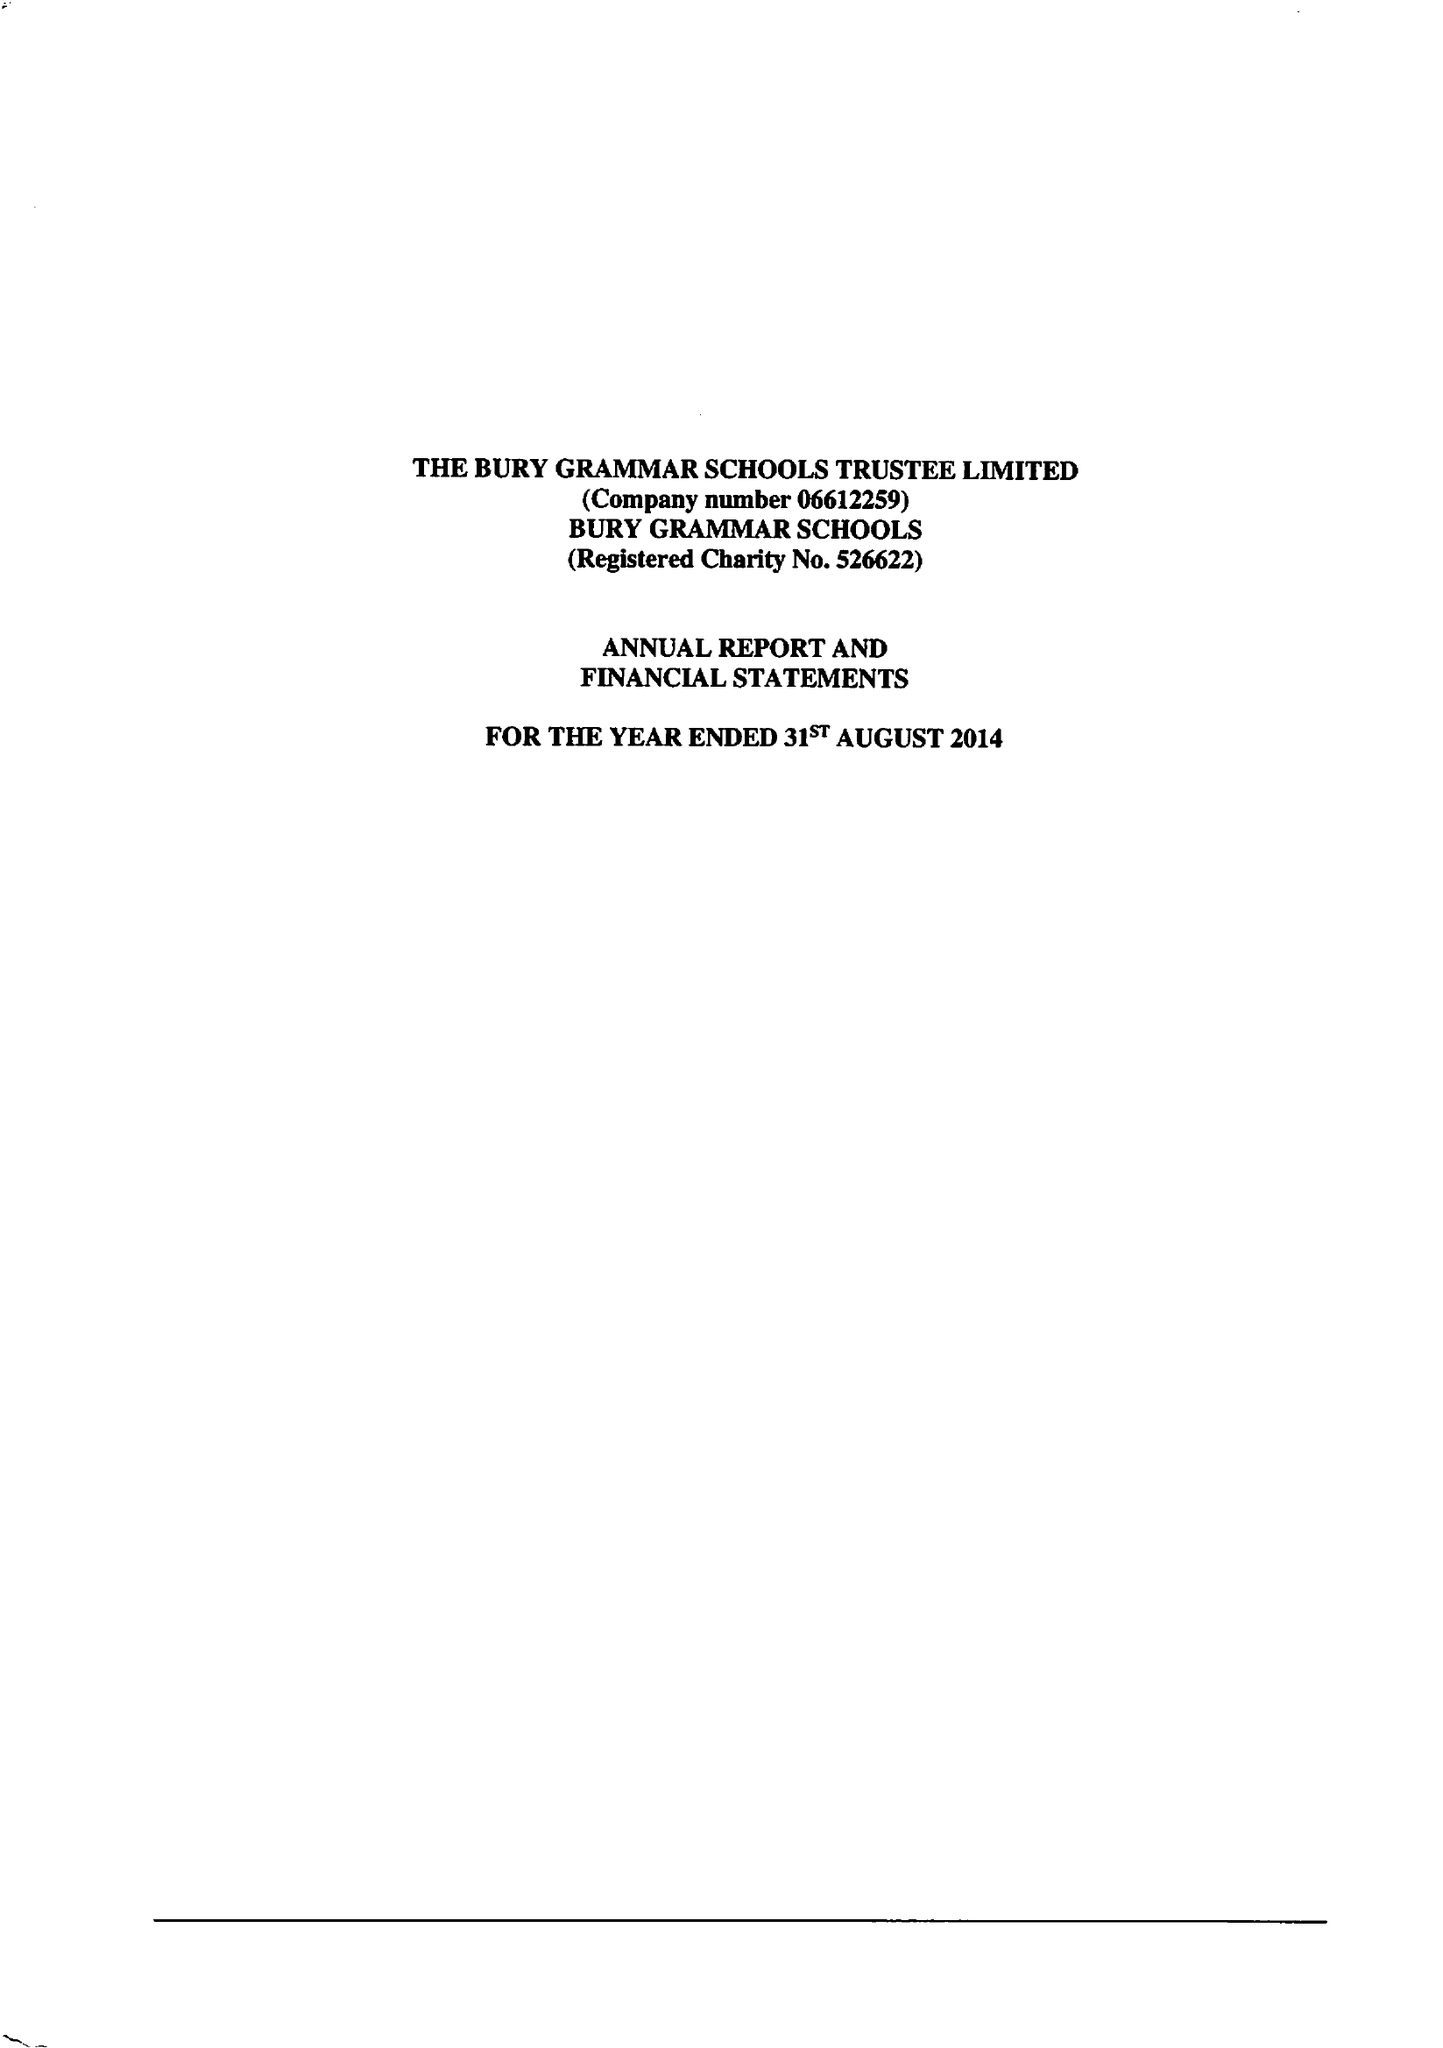What is the value for the address__postcode?
Answer the question using a single word or phrase. BL9 0HG 